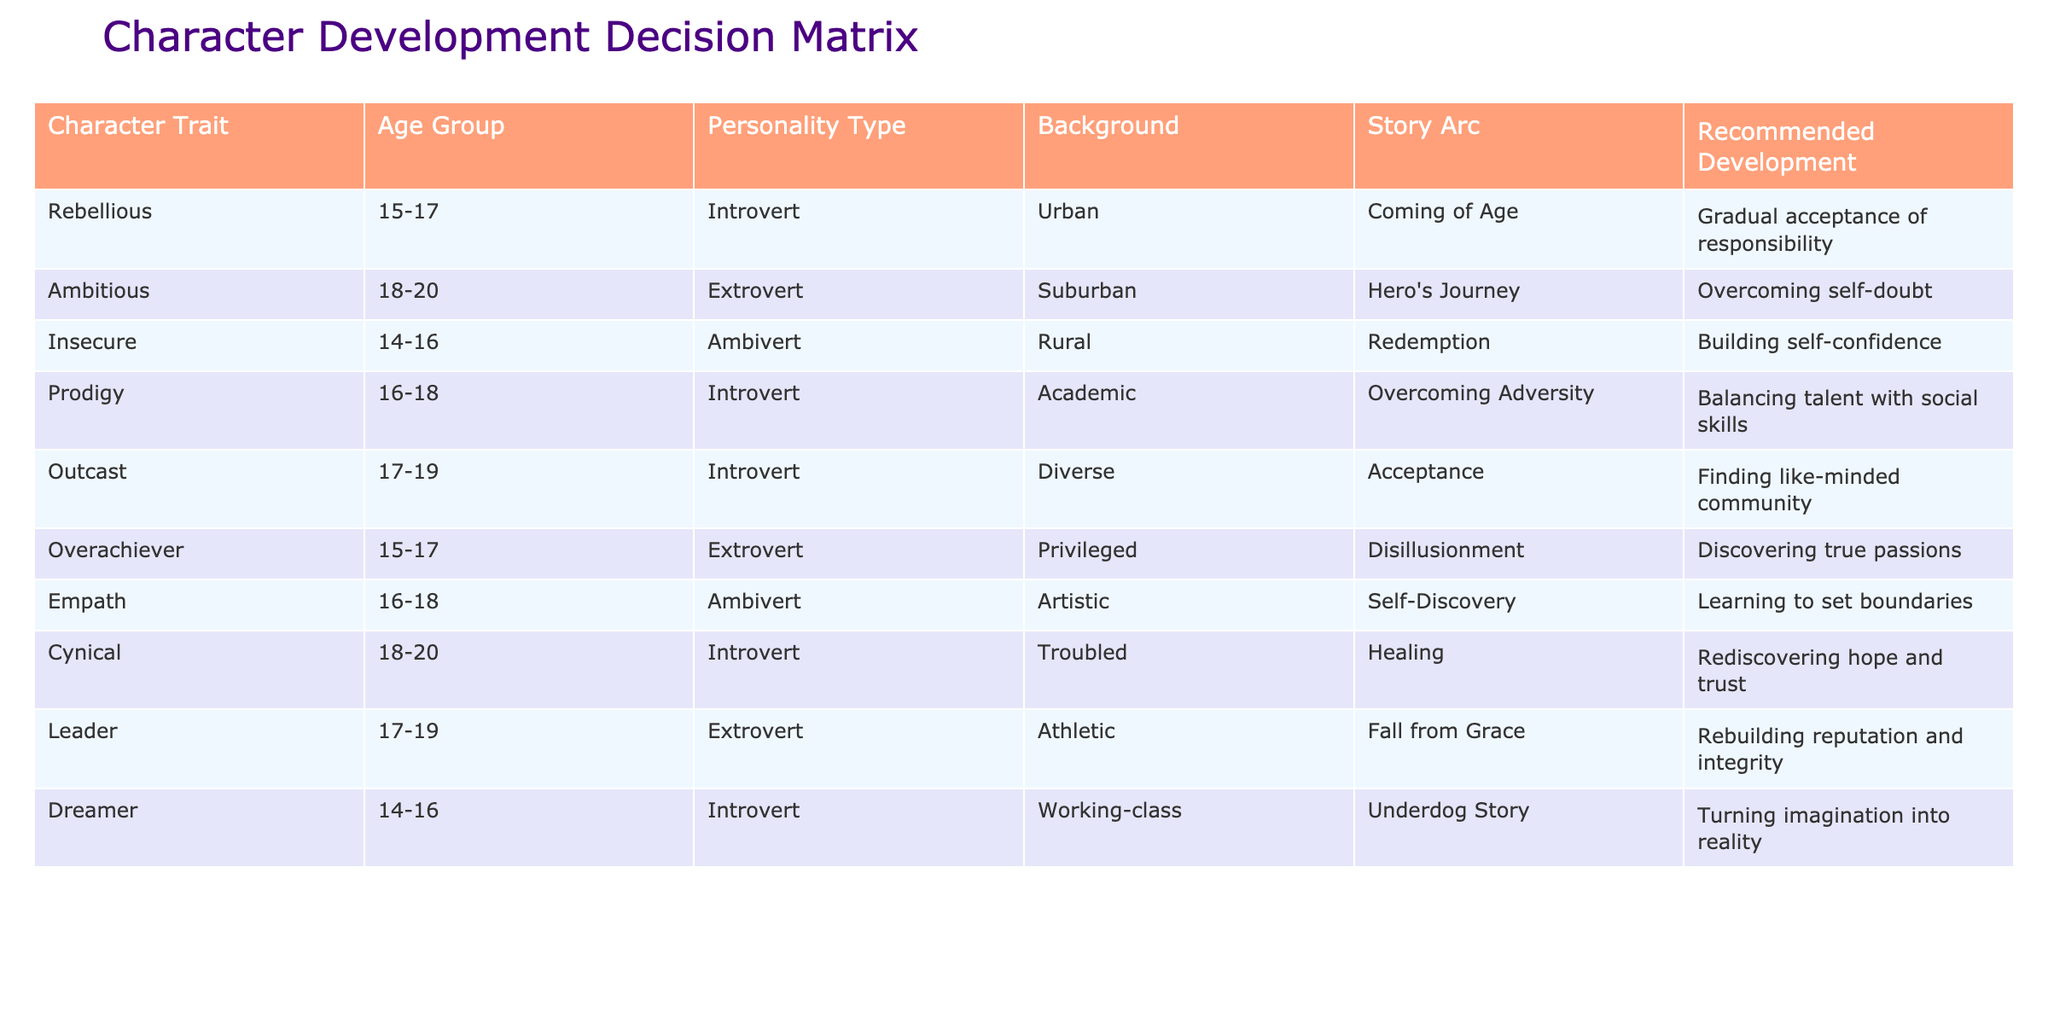What character trait is recommended for gradual acceptance of responsibility? The table indicates that the character trait recommended for gradual acceptance of responsibility is "Rebellious." This can be found in the first row of the table under "Recommended Development."
Answer: Rebellious Which personality type corresponds with the "Hero's Journey" story arc? The table lists "Extrovert" as the personality type corresponding to the "Hero's Journey" story arc. This is seen in the second row where both personality type and story arc are aligned.
Answer: Extrovert Are there any characters with the Insecure trait that belong to the age group 14-16? Yes, the table shows that the "Insecure" trait is associated with the age group 14-16 in the third row. Thus, the answer is affirmative.
Answer: Yes What is the recommended development for the character trait "Prodigy"? The recommended development for the "Prodigy" trait is "Balancing talent with social skills," which can be found in the fourth row of the table under "Recommended Development."
Answer: Balancing talent with social skills How many characters have a personality type categorized as "Introvert"? From the table, there are five characters that have the personality type "Introvert": Rebellious, Prodigy, Outcast, Cynical, and Dreamer. This can be obtained by counting the rows that list "Introvert" as the personality type.
Answer: Five Which character trait is associated with "Finding like-minded community"? The table indicates that "Outcast" is the character trait associated with "Finding like-minded community." This is located in the fifth row under "Recommended Development."
Answer: Outcast What is the average age range of characters with the trait "Overachiever"? The age range for the "Overachiever" trait is 15-17. To find the average, we convert the range to numerical values (15 + 17 = 32, then 32 / 2 = 16). Hence, the average age is 16.
Answer: 16 Is there a character with the trait "Leader" whose background is categorized as "Athletic"? Yes, the character trait "Leader" is indeed associated with the background "Athletic," as indicated in the eighth row of the table. Hence the fact is true.
Answer: Yes Which character in the age group 18-20 is categorized as "Cynical"? The "Cynical" character is associated with the age group 18-20, according to the table displayed in the sixth row. Therefore, the answer is "Cynical."
Answer: Cynical 